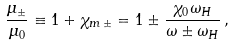<formula> <loc_0><loc_0><loc_500><loc_500>\frac { \mu _ { \pm } } { \mu _ { 0 } } \equiv 1 + \chi _ { m \, \pm } = 1 \pm \frac { \chi _ { 0 } \omega _ { H } } { \omega \pm \omega _ { H } } \, ,</formula> 